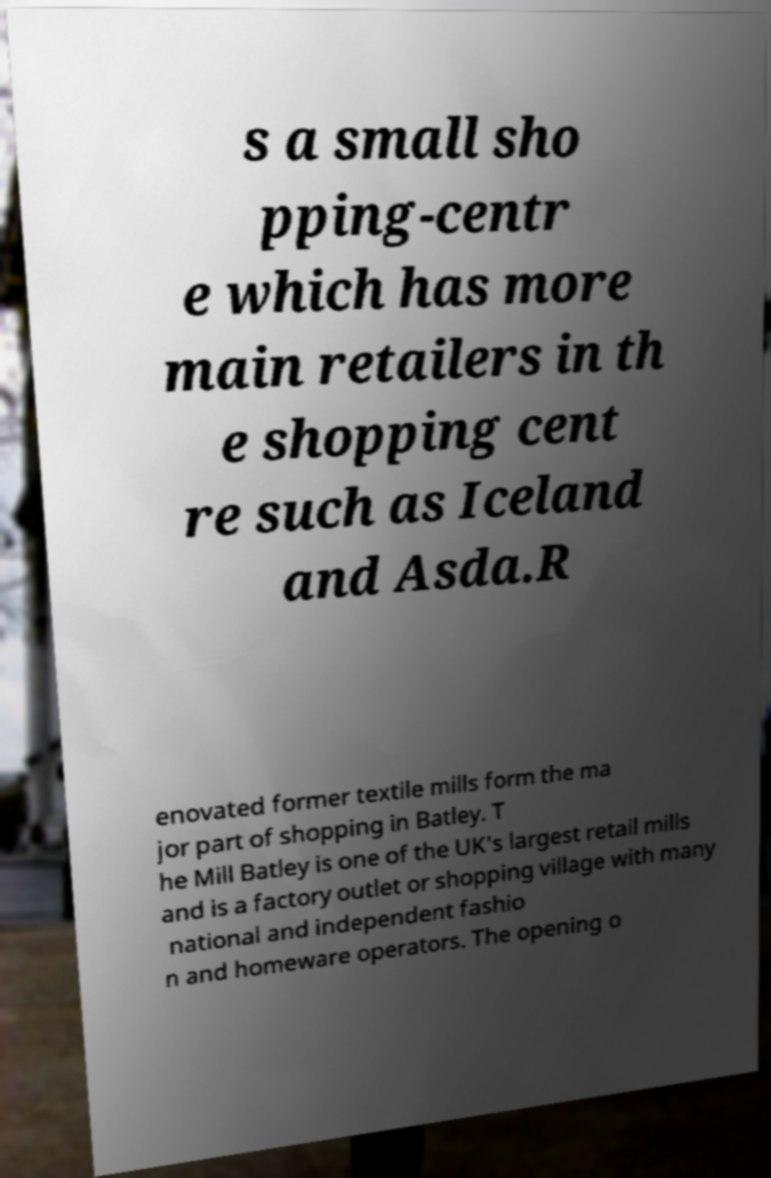Can you read and provide the text displayed in the image?This photo seems to have some interesting text. Can you extract and type it out for me? s a small sho pping-centr e which has more main retailers in th e shopping cent re such as Iceland and Asda.R enovated former textile mills form the ma jor part of shopping in Batley. T he Mill Batley is one of the UK's largest retail mills and is a factory outlet or shopping village with many national and independent fashio n and homeware operators. The opening o 